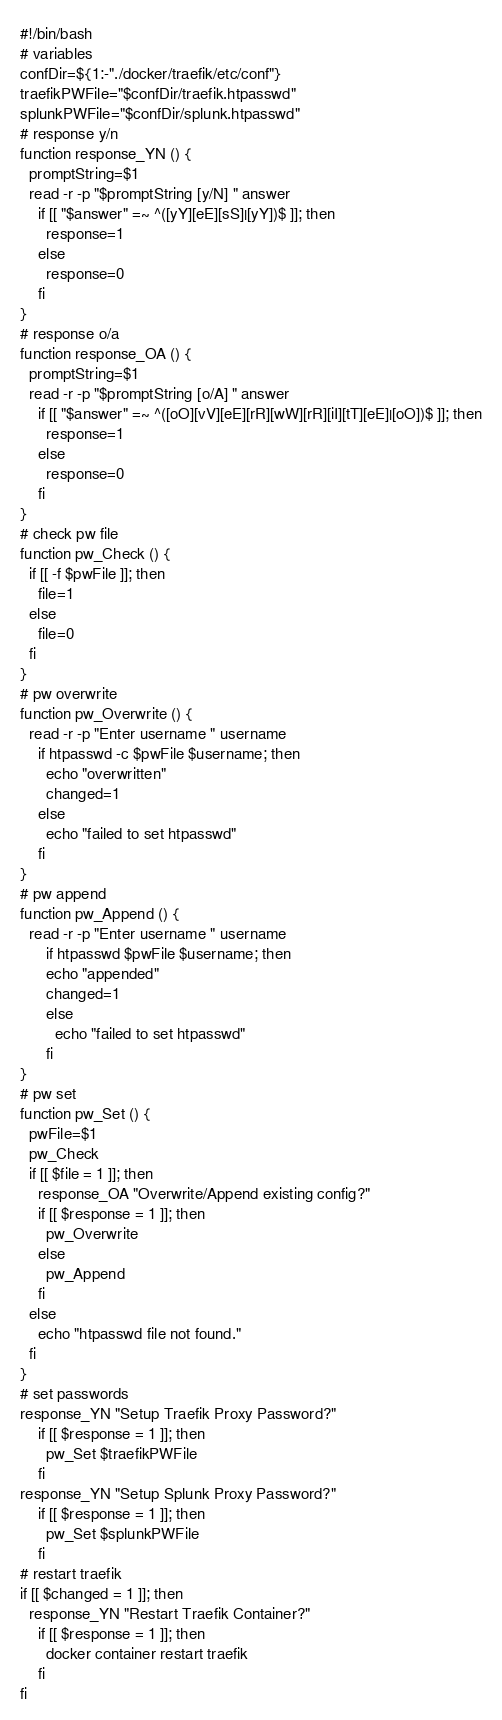<code> <loc_0><loc_0><loc_500><loc_500><_Bash_>#!/bin/bash
# variables
confDir=${1:-"./docker/traefik/etc/conf"}
traefikPWFile="$confDir/traefik.htpasswd"
splunkPWFile="$confDir/splunk.htpasswd"
# response y/n
function response_YN () {
  promptString=$1
  read -r -p "$promptString [y/N] " answer
    if [[ "$answer" =~ ^([yY][eE][sS]|[yY])$ ]]; then
      response=1
    else
      response=0
    fi
}
# response o/a
function response_OA () {
  promptString=$1
  read -r -p "$promptString [o/A] " answer
    if [[ "$answer" =~ ^([oO][vV][eE][rR][wW][rR][iI][tT][eE]|[oO])$ ]]; then
      response=1
    else
      response=0
    fi
}
# check pw file
function pw_Check () {
  if [[ -f $pwFile ]]; then
    file=1
  else
    file=0
  fi
}
# pw overwrite
function pw_Overwrite () {
  read -r -p "Enter username " username
    if htpasswd -c $pwFile $username; then
      echo "overwritten"
      changed=1
    else
      echo "failed to set htpasswd"
    fi
}
# pw append
function pw_Append () {
  read -r -p "Enter username " username
      if htpasswd $pwFile $username; then
      echo "appended"
      changed=1
      else
        echo "failed to set htpasswd"
      fi
}
# pw set
function pw_Set () {
  pwFile=$1
  pw_Check
  if [[ $file = 1 ]]; then
    response_OA "Overwrite/Append existing config?"
    if [[ $response = 1 ]]; then
      pw_Overwrite
    else
      pw_Append
    fi
  else
    echo "htpasswd file not found."
  fi
}
# set passwords
response_YN "Setup Traefik Proxy Password?"
    if [[ $response = 1 ]]; then
      pw_Set $traefikPWFile
    fi
response_YN "Setup Splunk Proxy Password?"
    if [[ $response = 1 ]]; then
      pw_Set $splunkPWFile
    fi
# restart traefik
if [[ $changed = 1 ]]; then
  response_YN "Restart Traefik Container?"
    if [[ $response = 1 ]]; then
      docker container restart traefik
    fi
fi</code> 